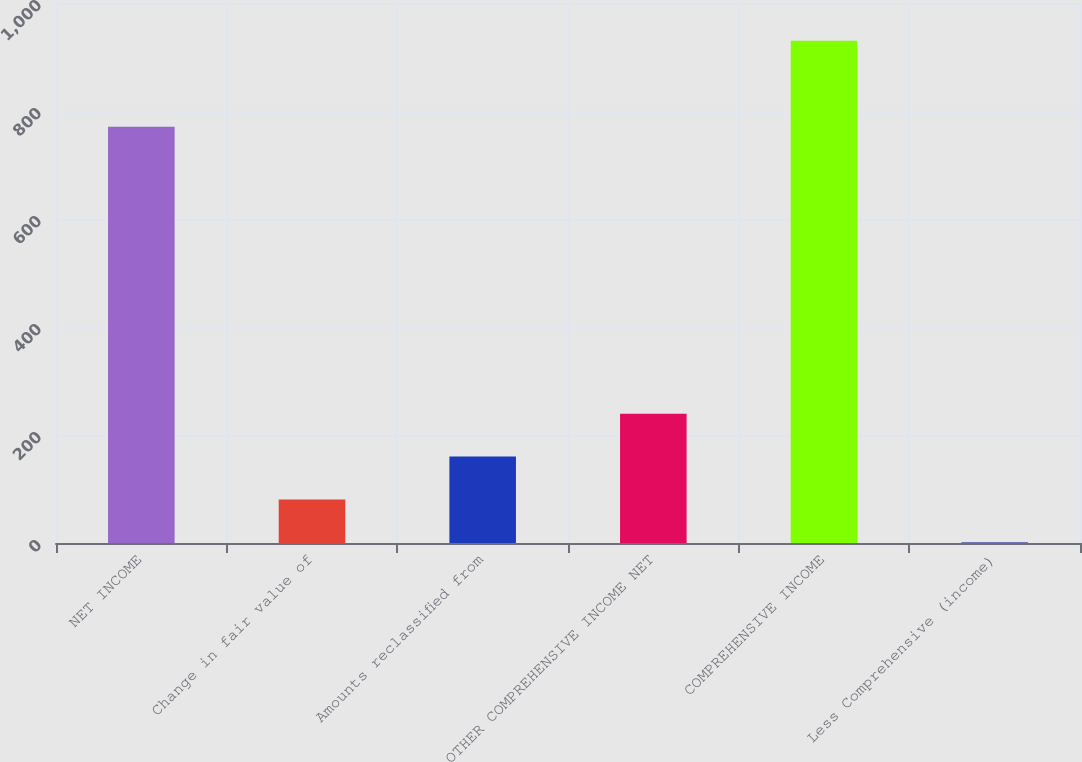<chart> <loc_0><loc_0><loc_500><loc_500><bar_chart><fcel>NET INCOME<fcel>Change in fair value of<fcel>Amounts reclassified from<fcel>OTHER COMPREHENSIVE INCOME NET<fcel>COMPREHENSIVE INCOME<fcel>Less Comprehensive (income)<nl><fcel>771<fcel>80.5<fcel>160<fcel>239.5<fcel>930<fcel>1<nl></chart> 